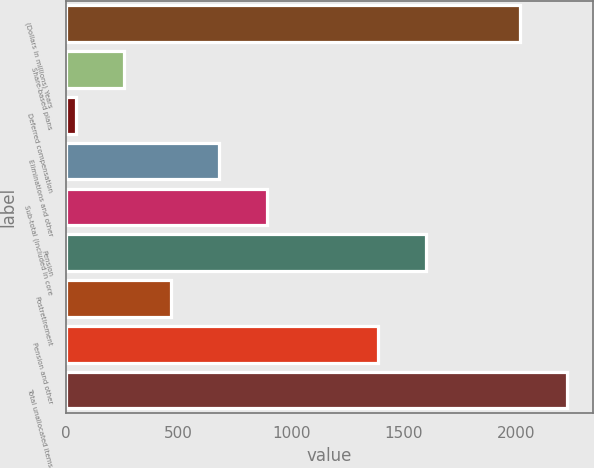Convert chart to OTSL. <chart><loc_0><loc_0><loc_500><loc_500><bar_chart><fcel>(Dollars in millions) Years<fcel>Share-based plans<fcel>Deferred compensation<fcel>Eliminations and other<fcel>Sub-total (included in core<fcel>Pension<fcel>Postretirement<fcel>Pension and other<fcel>Total unallocated items<nl><fcel>2014<fcel>255.9<fcel>44<fcel>679.7<fcel>891.6<fcel>1598.9<fcel>467.8<fcel>1387<fcel>2225.9<nl></chart> 